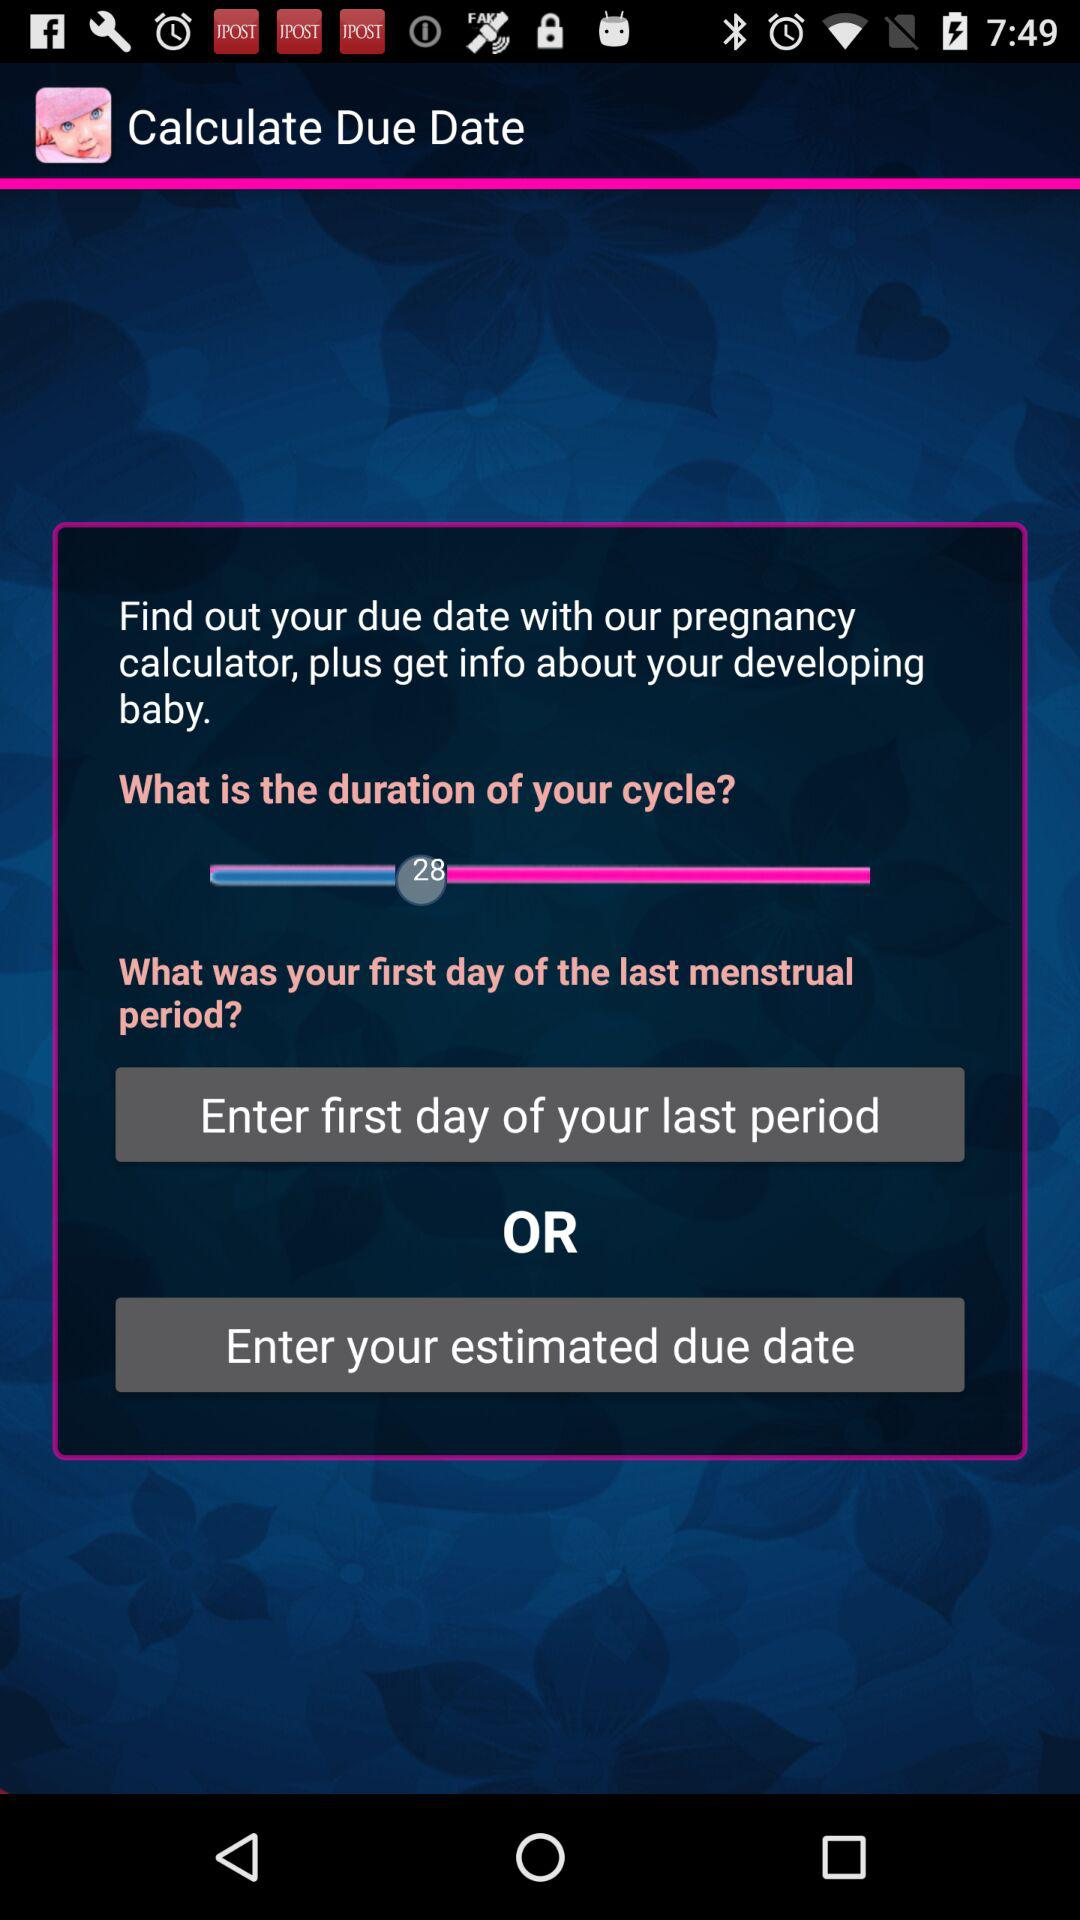How many days long is the user's cycle?
Answer the question using a single word or phrase. 28 